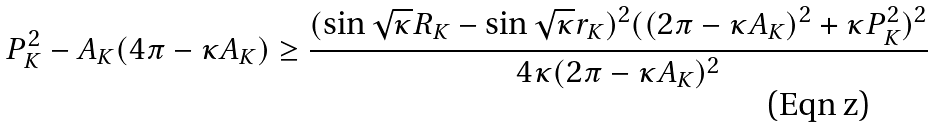Convert formula to latex. <formula><loc_0><loc_0><loc_500><loc_500>P _ { K } ^ { 2 } - A _ { K } ( 4 \pi - \kappa A _ { K } ) \geq \frac { ( \sin \sqrt { \kappa } R _ { K } - \sin \sqrt { \kappa } r _ { K } ) ^ { 2 } ( ( 2 \pi - \kappa A _ { K } ) ^ { 2 } + \kappa P _ { K } ^ { 2 } ) ^ { 2 } } { 4 \kappa ( 2 \pi - \kappa A _ { K } ) ^ { 2 } }</formula> 